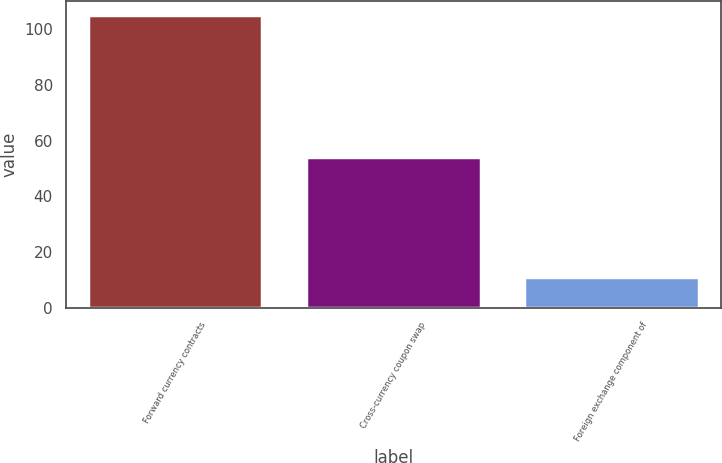Convert chart to OTSL. <chart><loc_0><loc_0><loc_500><loc_500><bar_chart><fcel>Forward currency contracts<fcel>Cross-currency coupon swap<fcel>Foreign exchange component of<nl><fcel>105<fcel>54<fcel>11<nl></chart> 